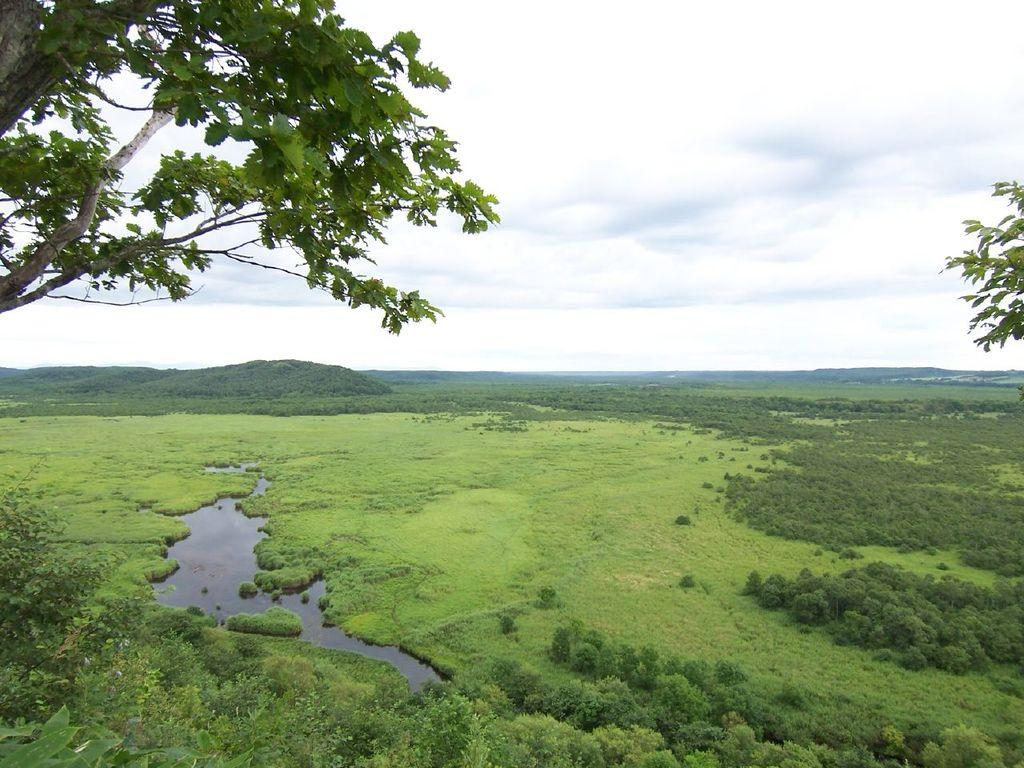What body of water is located on the left side of the image? There is a pond on the left side of the image. What type of vegetation covers the land around the pond? The land around the pond is covered with grass. What type of plants can be seen in the image? There are trees in the image. What geographical feature is visible in the background of the image? There is a hill in the background of the image. What part of the natural environment is visible in the image? The sky is visible in the image. What atmospheric conditions can be observed in the sky? Clouds are present in the sky. What type of paint is being used to create the humorous effect in the image? There is no paint or humor present in the image; it is a natural scene featuring a pond, grass, trees, a hill, and a sky with clouds. How many matches are visible in the image? There are no matches present in the image. 